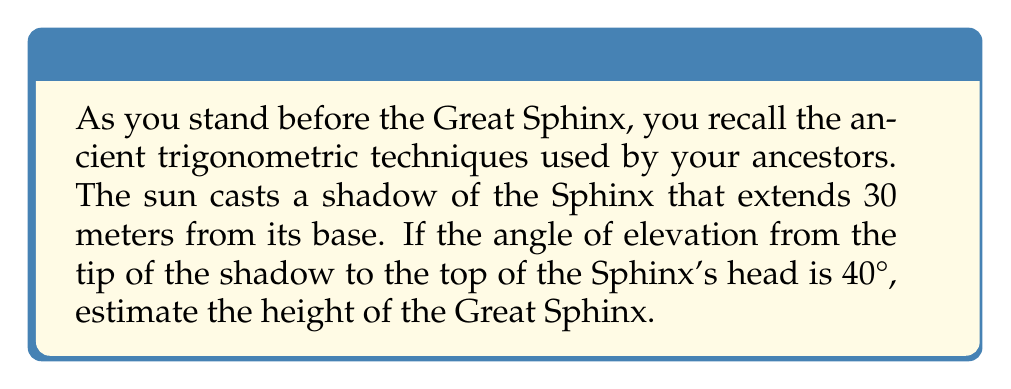Teach me how to tackle this problem. Let's approach this step-by-step using trigonometry:

1) First, we need to visualize the problem. The Sphinx, its shadow, and the sun's rays form a right triangle.

[asy]
import geometry;

size(200);
pair A = (0,0), B = (6,0), C = (6,5);
draw(A--B--C--A);
label("30 m", (A+B)/2, S);
label("h", (B+C)/2, E);
label("40°", A, SW);
draw(rightanglemark(A,B,C));
[/asy]

2) In this triangle:
   - The adjacent side is the length of the shadow (30 meters)
   - The opposite side is the height of the Sphinx (h)
   - The angle of elevation is 40°

3) We can use the tangent function to find the height. Recall that:

   $$\tan(\theta) = \frac{\text{opposite}}{\text{adjacent}}$$

4) Plugging in our values:

   $$\tan(40°) = \frac{h}{30}$$

5) To solve for h, we multiply both sides by 30:

   $$30 \cdot \tan(40°) = h$$

6) Now we can calculate:
   
   $$h = 30 \cdot \tan(40°) \approx 30 \cdot 0.8391 \approx 25.17 \text{ meters}$$

7) Rounding to the nearest meter, we estimate the height of the Great Sphinx to be 25 meters.
Answer: 25 meters 